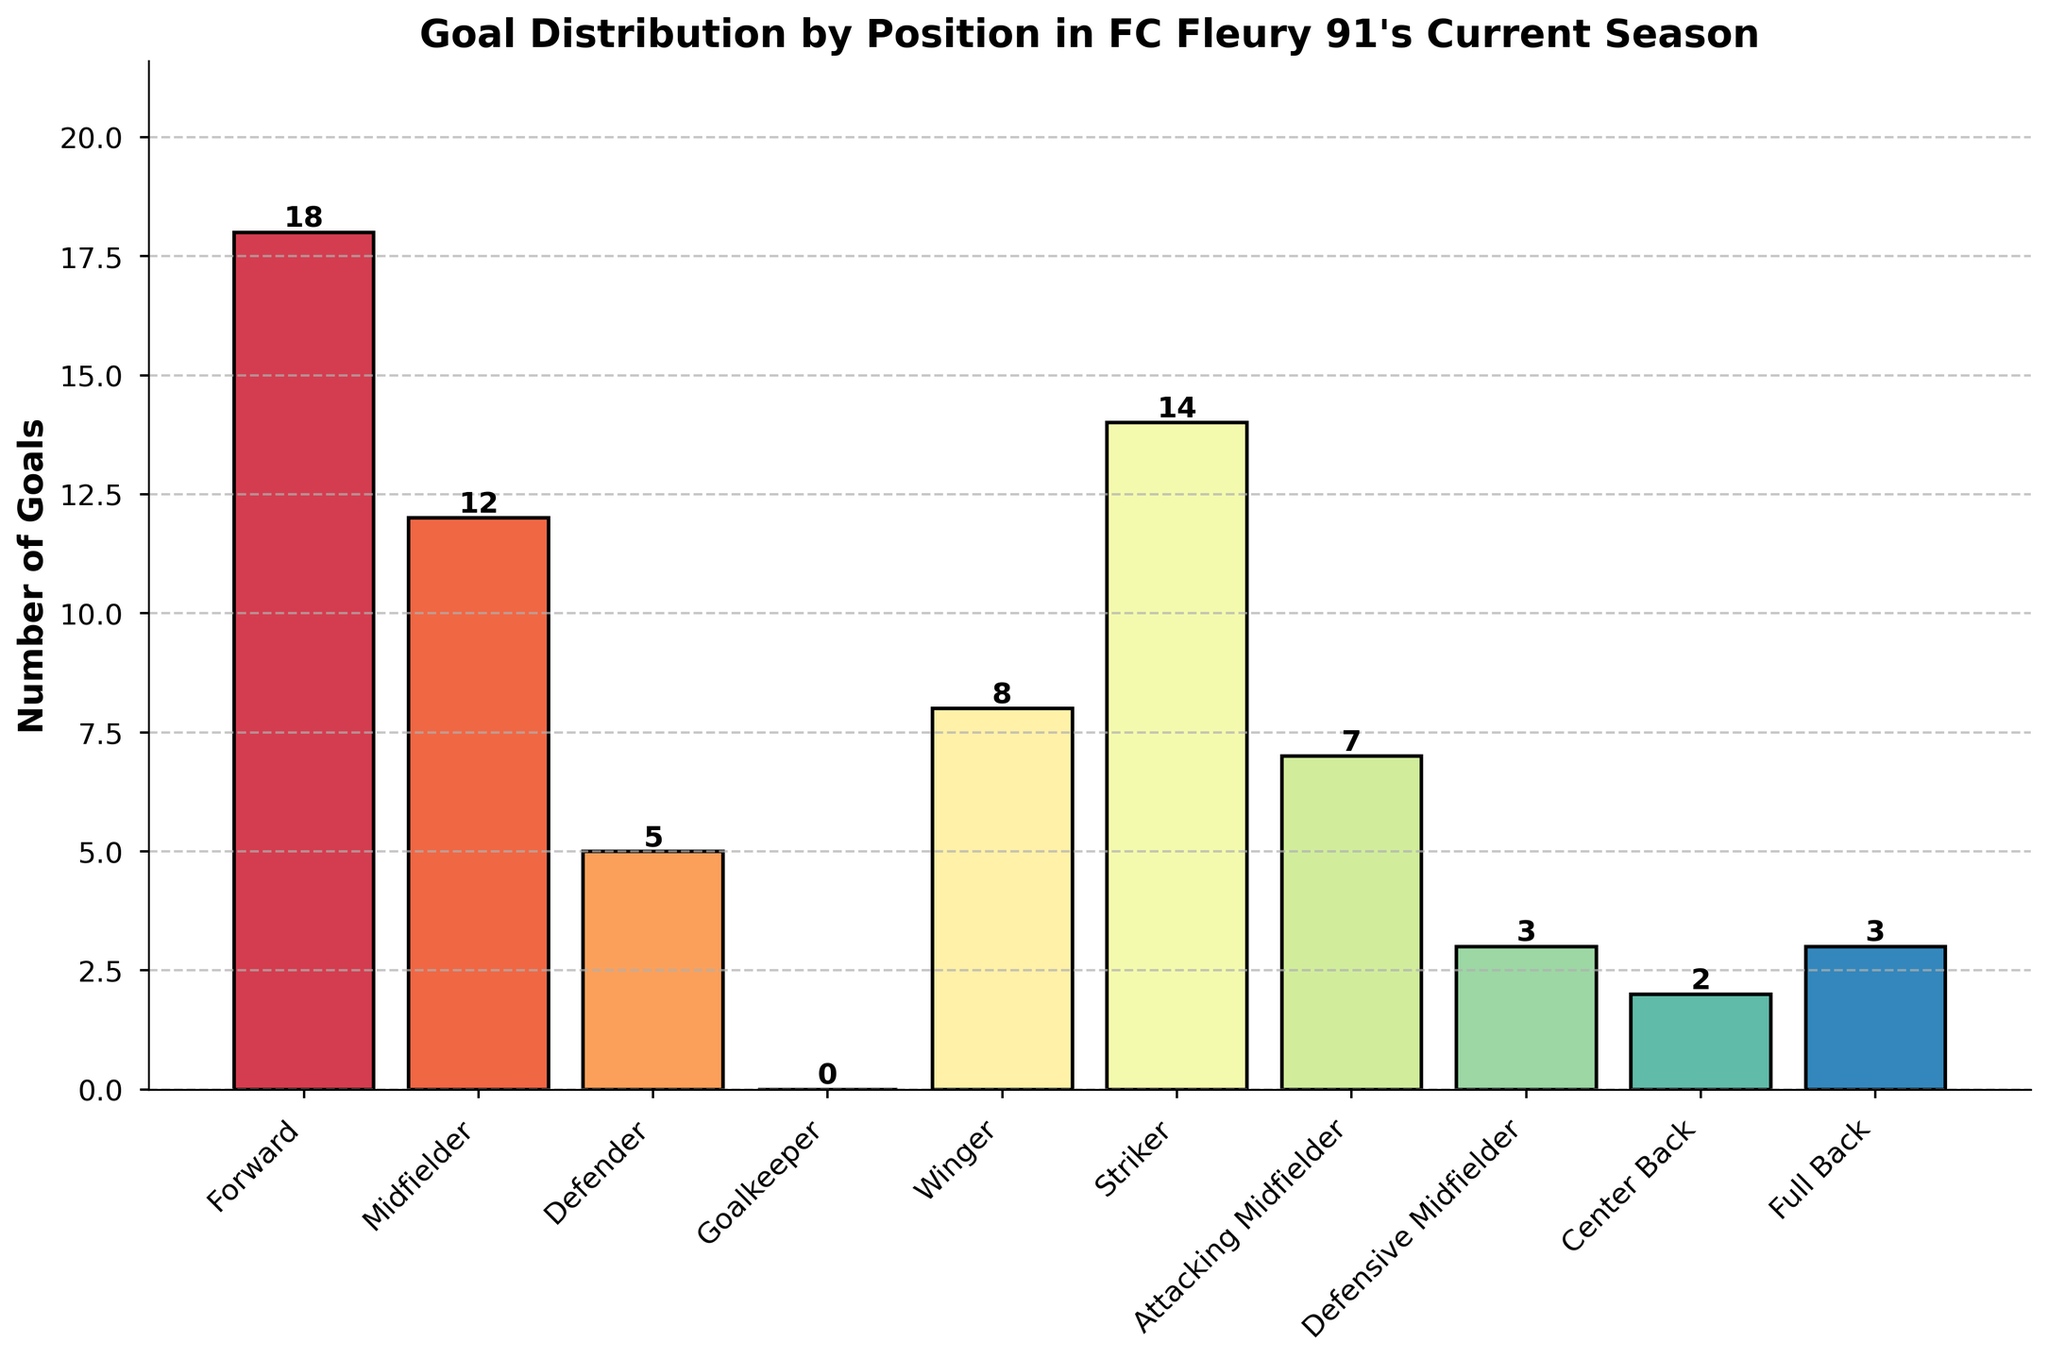What position scored the most goals? To determine which position scored the most goals, we need to look for the tallest bar in the bar chart. The "Forward" position has the highest bar, indicating it has scored the most goals.
Answer: Forward How many more goals did the "Striker" score compared to the "Defender"? We compare the height (or numerical value) of the goals scored by "Striker" and "Defender". The "Striker" scored 14 goals and the "Defender" scored 5. The difference is 14 - 5 = 9.
Answer: 9 What is the total number of goals scored by "Midfielders" and "Attacking Midfielders"? Add the goals scored by "Midfielders" (12) and "Attacking Midfielders" (7). The total is 12 + 7 = 19.
Answer: 19 Which position scored more goals: "Wingers" or "Defensive Midfielders," and by how much? Compare the goals scored by the "Wingers" (8) and "Defensive Midfielders" (3). The "Wingers" scored more, and the difference is 8 - 3 = 5.
Answer: Wingers, 5 Are there any positions with the same number of goals scored? If so, which ones? Look for bars that reach the same height. "Defensive Midfielders" and "Full Backs" each scored 3 goals.
Answer: Defensive Midfielders, Full Backs What is the average number of goals scored per position? Sum all goals scored and divide by the number of positions. Total goals = 18 + 12 + 5 + 0 + 8 + 14 + 7 + 3 + 2 + 3 = 72. Number of positions = 10. Average = 72 / 10 = 7.2
Answer: 7.2 By how much do the goals scored by the top 3 positions exceed those scored by the bottom 3 positions? Identify the top 3 (Forward: 18, Striker: 14, Midfielder: 12) and bottom 3 (Center Back: 2, Goalkeeper: 0, Full Back: 3) positions and calculate their goals. Sum top 3: 18 + 14 + 12 = 44; bottom 3: 2 + 0 + 3 = 5. Difference: 44 - 5 = 39.
Answer: 39 